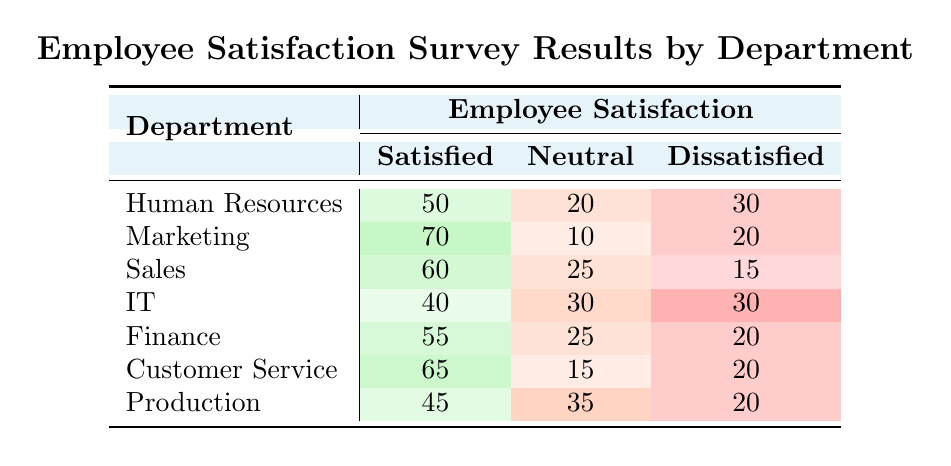What is the number of satisfied employees in the Marketing department? The Marketing department has 70 satisfied employees listed in the table under the "Satisfied" column.
Answer: 70 Which department has the highest number of dissatisfied employees? The IT department has the highest count of 30 dissatisfied employees, as seen in the "Dissatisfied" column.
Answer: IT What is the total number of satisfied employees across all departments? Adding the satisfied employees from all departments: 50 (HR) + 70 (Marketing) + 60 (Sales) + 40 (IT) + 55 (Finance) + 65 (Customer Service) + 45 (Production) = 405.
Answer: 405 Is it true that the Sales department has more satisfied employees than the Human Resources department? Yes, the Sales department has 60 satisfied employees, while the Human Resources department has 50, making it true that Sales has more satisfied employees.
Answer: Yes What is the average number of dissatisfied employees across all departments? Adding the dissatisfied employees: 30 (HR) + 20 (Marketing) + 15 (Sales) + 30 (IT) + 20 (Finance) + 20 (Customer Service) + 20 (Production) = 165. There are 7 departments, so the average is 165/7 ≈ 23.57.
Answer: 23.57 